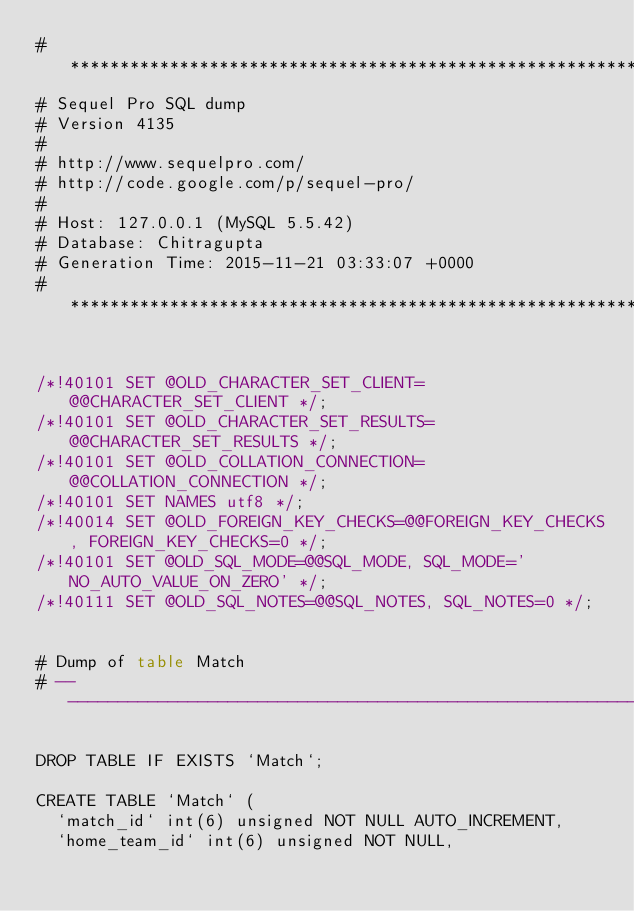Convert code to text. <code><loc_0><loc_0><loc_500><loc_500><_SQL_># ************************************************************
# Sequel Pro SQL dump
# Version 4135
#
# http://www.sequelpro.com/
# http://code.google.com/p/sequel-pro/
#
# Host: 127.0.0.1 (MySQL 5.5.42)
# Database: Chitragupta
# Generation Time: 2015-11-21 03:33:07 +0000
# ************************************************************


/*!40101 SET @OLD_CHARACTER_SET_CLIENT=@@CHARACTER_SET_CLIENT */;
/*!40101 SET @OLD_CHARACTER_SET_RESULTS=@@CHARACTER_SET_RESULTS */;
/*!40101 SET @OLD_COLLATION_CONNECTION=@@COLLATION_CONNECTION */;
/*!40101 SET NAMES utf8 */;
/*!40014 SET @OLD_FOREIGN_KEY_CHECKS=@@FOREIGN_KEY_CHECKS, FOREIGN_KEY_CHECKS=0 */;
/*!40101 SET @OLD_SQL_MODE=@@SQL_MODE, SQL_MODE='NO_AUTO_VALUE_ON_ZERO' */;
/*!40111 SET @OLD_SQL_NOTES=@@SQL_NOTES, SQL_NOTES=0 */;


# Dump of table Match
# ------------------------------------------------------------

DROP TABLE IF EXISTS `Match`;

CREATE TABLE `Match` (
  `match_id` int(6) unsigned NOT NULL AUTO_INCREMENT,
  `home_team_id` int(6) unsigned NOT NULL,</code> 